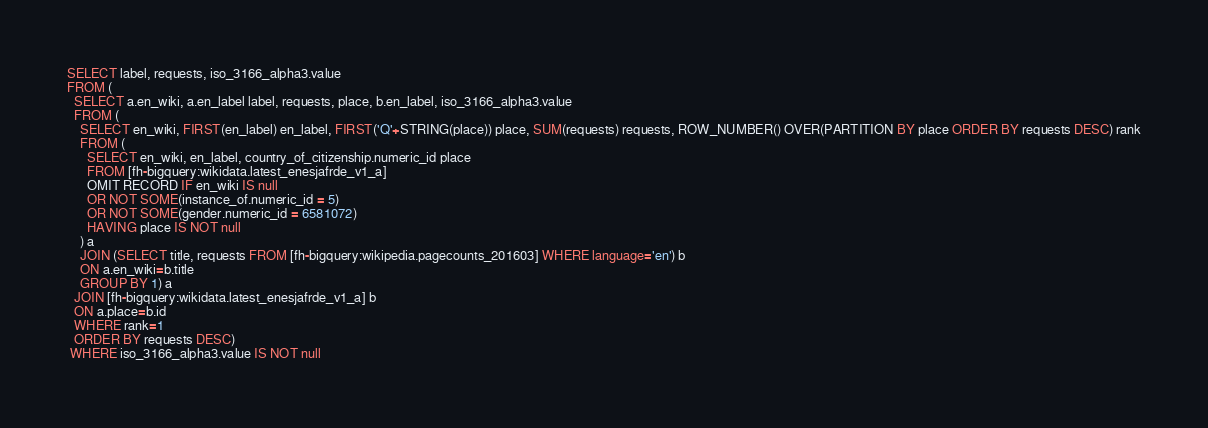Convert code to text. <code><loc_0><loc_0><loc_500><loc_500><_SQL_>SELECT label, requests, iso_3166_alpha3.value 
FROM (
  SELECT a.en_wiki, a.en_label label, requests, place, b.en_label, iso_3166_alpha3.value 
  FROM (
    SELECT en_wiki, FIRST(en_label) en_label, FIRST('Q'+STRING(place)) place, SUM(requests) requests, ROW_NUMBER() OVER(PARTITION BY place ORDER BY requests DESC) rank
    FROM ( 
      SELECT en_wiki, en_label, country_of_citizenship.numeric_id place
      FROM [fh-bigquery:wikidata.latest_enesjafrde_v1_a]
      OMIT RECORD IF en_wiki IS null
      OR NOT SOME(instance_of.numeric_id = 5)
      OR NOT SOME(gender.numeric_id = 6581072)  
      HAVING place IS NOT null
    ) a
    JOIN (SELECT title, requests FROM [fh-bigquery:wikipedia.pagecounts_201603] WHERE language='en') b
    ON a.en_wiki=b.title
    GROUP BY 1) a
  JOIN [fh-bigquery:wikidata.latest_enesjafrde_v1_a] b
  ON a.place=b.id
  WHERE rank=1
  ORDER BY requests DESC)
 WHERE iso_3166_alpha3.value IS NOT null
</code> 